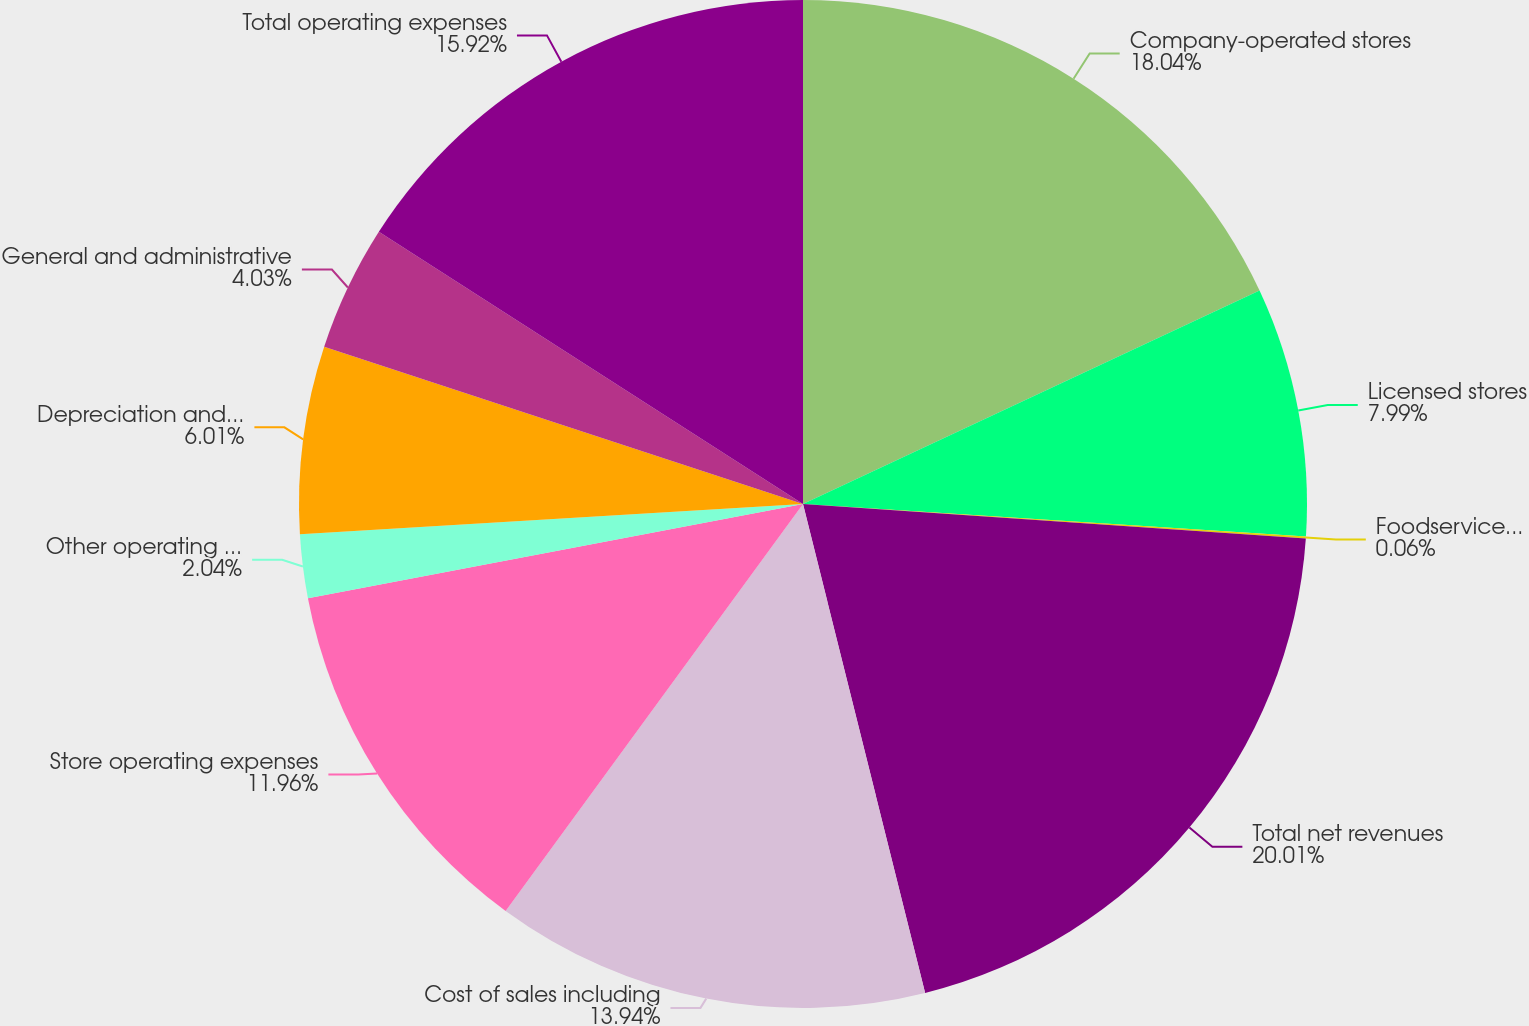Convert chart. <chart><loc_0><loc_0><loc_500><loc_500><pie_chart><fcel>Company-operated stores<fcel>Licensed stores<fcel>Foodservice and other<fcel>Total net revenues<fcel>Cost of sales including<fcel>Store operating expenses<fcel>Other operating expenses<fcel>Depreciation and amortization<fcel>General and administrative<fcel>Total operating expenses<nl><fcel>18.04%<fcel>7.99%<fcel>0.06%<fcel>20.02%<fcel>13.94%<fcel>11.96%<fcel>2.04%<fcel>6.01%<fcel>4.03%<fcel>15.92%<nl></chart> 